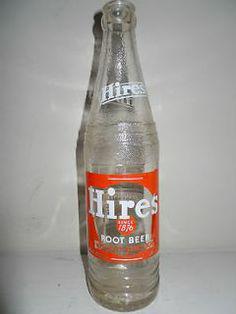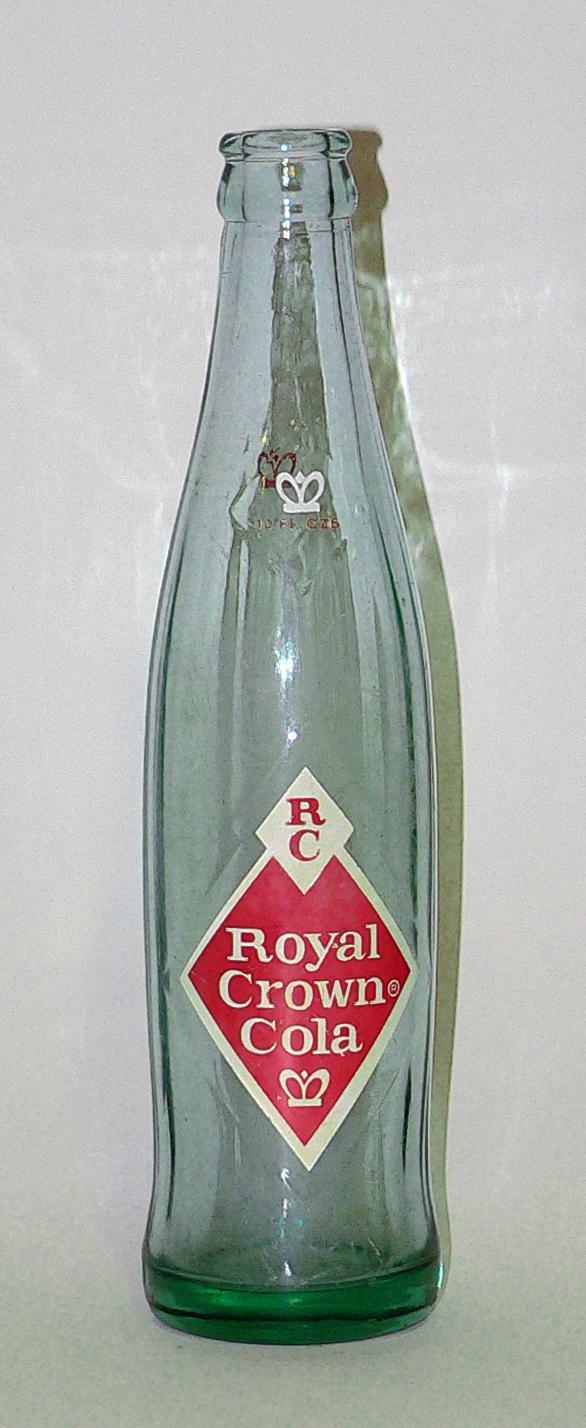The first image is the image on the left, the second image is the image on the right. Evaluate the accuracy of this statement regarding the images: "the left and right image contains the same number of glass bottles.". Is it true? Answer yes or no. Yes. The first image is the image on the left, the second image is the image on the right. Assess this claim about the two images: "there are two glass containers in the image pair". Correct or not? Answer yes or no. Yes. 